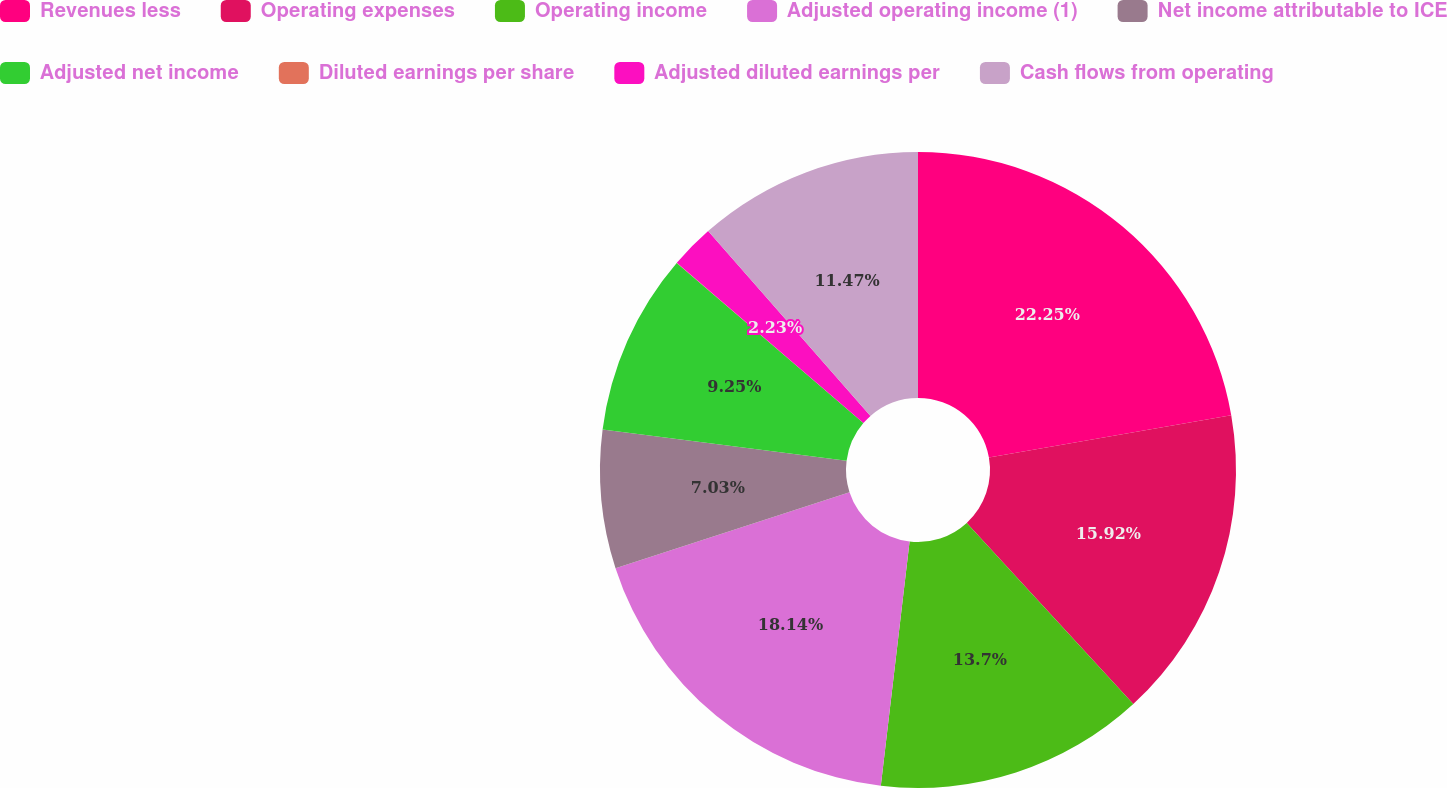Convert chart. <chart><loc_0><loc_0><loc_500><loc_500><pie_chart><fcel>Revenues less<fcel>Operating expenses<fcel>Operating income<fcel>Adjusted operating income (1)<fcel>Net income attributable to ICE<fcel>Adjusted net income<fcel>Diluted earnings per share<fcel>Adjusted diluted earnings per<fcel>Cash flows from operating<nl><fcel>22.24%<fcel>15.92%<fcel>13.7%<fcel>18.14%<fcel>7.03%<fcel>9.25%<fcel>0.01%<fcel>2.23%<fcel>11.47%<nl></chart> 